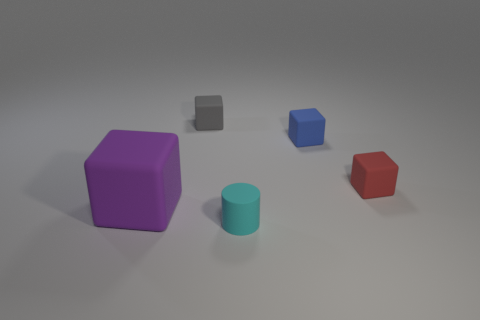There is a object that is in front of the matte object that is on the left side of the small gray matte object; what is its size?
Your answer should be very brief. Small. Is there anything else of the same color as the cylinder?
Offer a very short reply. No. Is the material of the block in front of the tiny red rubber object the same as the tiny object in front of the large object?
Your response must be concise. Yes. What material is the small object that is in front of the blue thing and behind the large purple thing?
Your response must be concise. Rubber. There is a gray thing; is its shape the same as the tiny object that is in front of the big purple block?
Your answer should be compact. No. What is the material of the small thing that is in front of the object left of the tiny rubber thing to the left of the tiny cyan cylinder?
Your response must be concise. Rubber. How many other objects are the same size as the purple block?
Your response must be concise. 0. Is the cylinder the same color as the large cube?
Provide a succinct answer. No. There is a thing that is on the left side of the tiny matte block to the left of the tiny cyan matte thing; how many small blue things are to the left of it?
Ensure brevity in your answer.  0. The small object that is in front of the cube that is on the left side of the tiny gray cube is made of what material?
Keep it short and to the point. Rubber. 